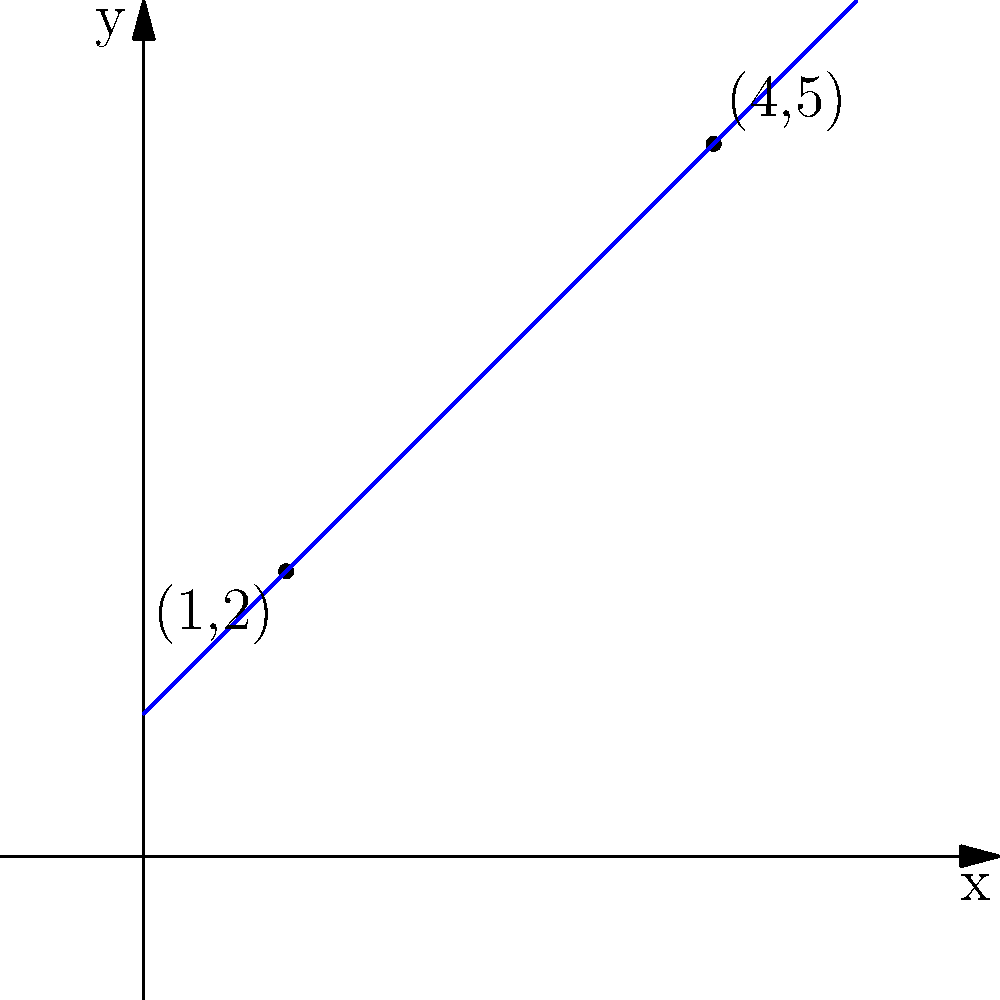As the accountant responsible for tracking the club's financial growth, you need to determine the equation of the line representing the trend in membership fees over time. Given two data points: (1,2) representing the fee after one year, and (4,5) representing the fee after four years, find the equation of the line passing through these points in slope-intercept form $(y = mx + b)$. To find the equation of a line passing through two points, we can follow these steps:

1. Calculate the slope $(m)$ using the slope formula:
   $m = \frac{y_2 - y_1}{x_2 - x_1} = \frac{5 - 2}{4 - 1} = \frac{3}{3} = 1$

2. Use the point-slope form of a line $(y - y_1 = m(x - x_1))$ with either point. Let's use (1,2):
   $y - 2 = 1(x - 1)$

3. Expand the equation:
   $y - 2 = x - 1$

4. Solve for $y$ to get the slope-intercept form $(y = mx + b)$:
   $y = x - 1 + 2$
   $y = x + 1$

Therefore, the equation of the line in slope-intercept form is $y = x + 1$.
Answer: $y = x + 1$ 